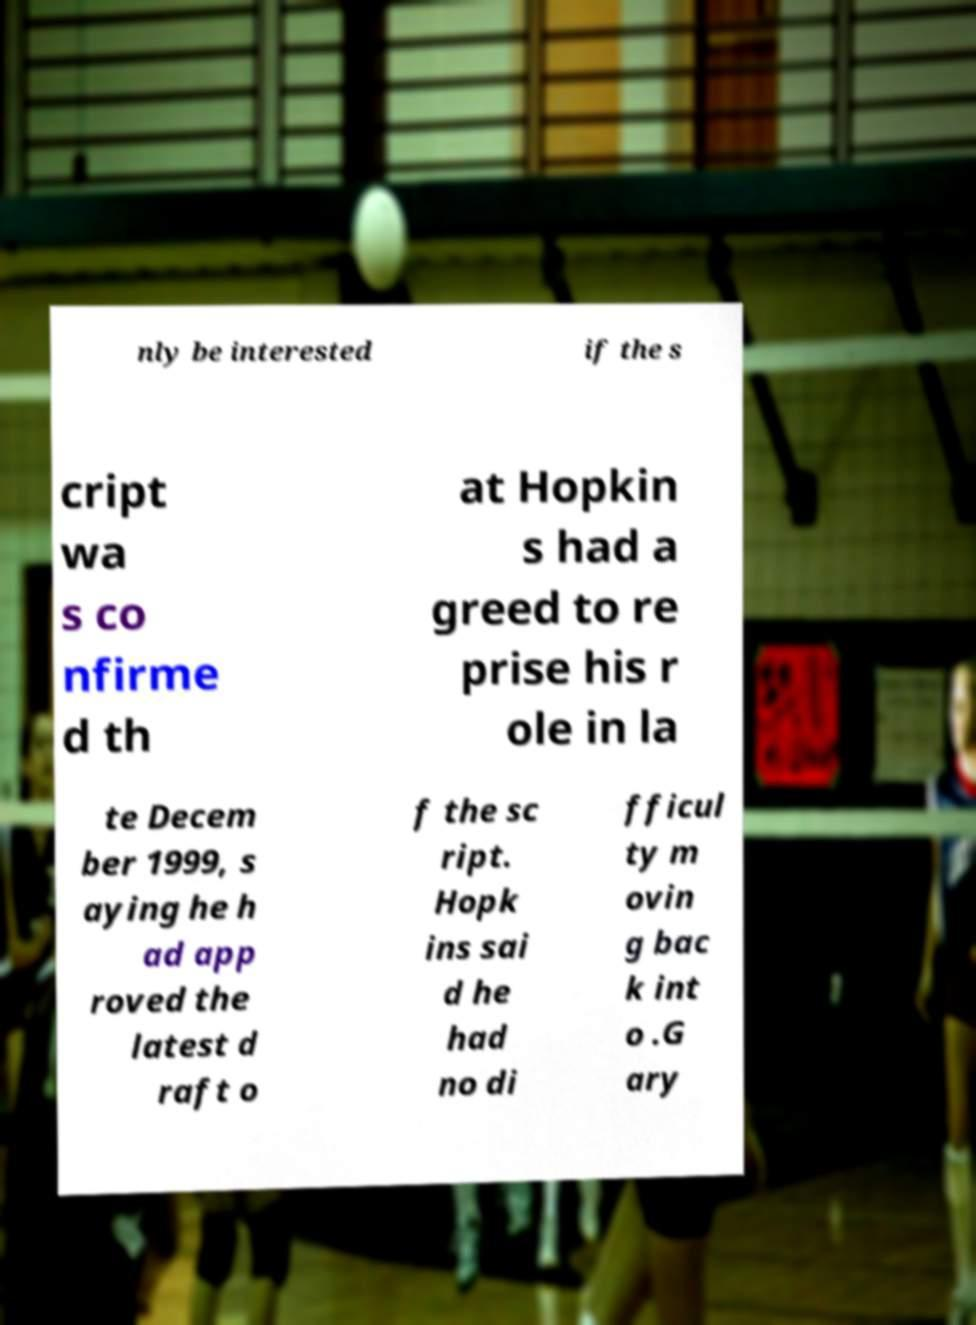Could you extract and type out the text from this image? nly be interested if the s cript wa s co nfirme d th at Hopkin s had a greed to re prise his r ole in la te Decem ber 1999, s aying he h ad app roved the latest d raft o f the sc ript. Hopk ins sai d he had no di fficul ty m ovin g bac k int o .G ary 